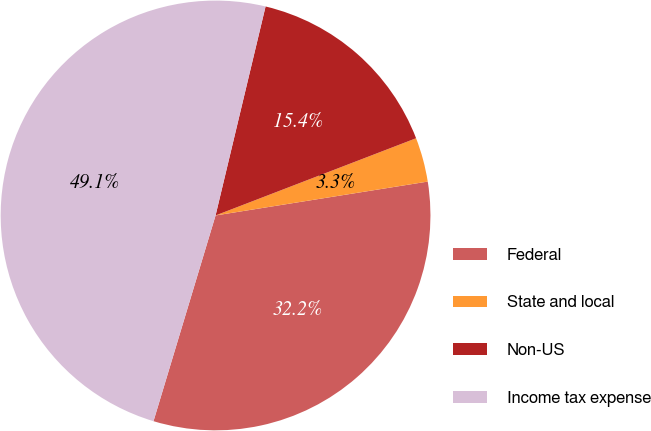Convert chart. <chart><loc_0><loc_0><loc_500><loc_500><pie_chart><fcel>Federal<fcel>State and local<fcel>Non-US<fcel>Income tax expense<nl><fcel>32.18%<fcel>3.33%<fcel>15.41%<fcel>49.07%<nl></chart> 